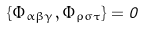Convert formula to latex. <formula><loc_0><loc_0><loc_500><loc_500>\{ \Phi _ { \alpha \beta \gamma } , \Phi _ { \rho \sigma \tau } \} = 0</formula> 